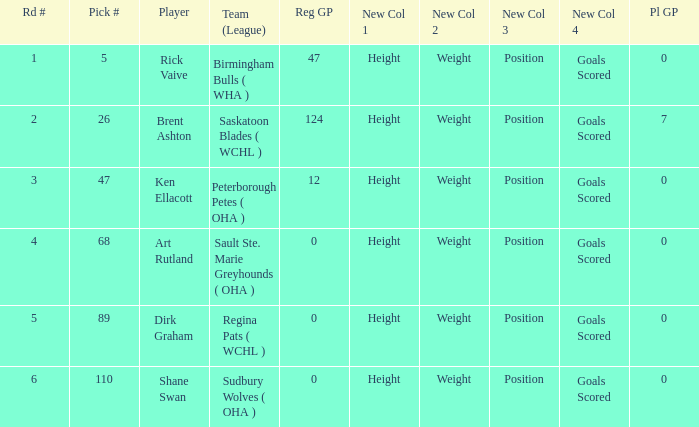How many reg GP for rick vaive in round 1? None. 